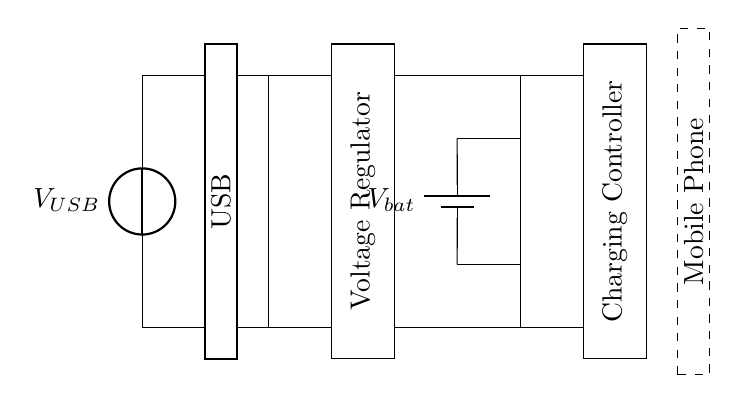What is the power source for this circuit? The power source for this circuit is a USB voltage source, indicated as V_USB. It is shown at the left side of the diagram and represents the input voltage that will charge the battery.
Answer: USB What component regulates the voltage in this circuit? The voltage regulation in this circuit is handled by the component labeled as Voltage Regulator. This component receives input voltage from the USB and ensures the output voltage is appropriate for charging the battery.
Answer: Voltage Regulator How many main components are visible in the circuit? There are five main components visible in the circuit: USB source, Voltage Regulator, Battery, Charging Controller, and Mobile Phone body. These elements work together to allow charging of the mobile device’s battery.
Answer: Five What does the battery symbol represent? The battery symbol represents V_bat, which indicates the battery in the circuit. It is responsible for storing the electrical energy that powers the mobile phone once charged.
Answer: Battery What is the purpose of the charging controller? The charging controller controls the flow of current from the voltage regulator to the battery, ensuring that the battery is charged safely and effectively while preventing overcharging.
Answer: Current control What voltage does the charging controller typically output? The charging controller typically outputs a voltage consistent with the battery's charging specifications, generally around 4.2V for lithium-ion batteries, which ensures maximum efficiency without risking battery damage.
Answer: 4.2V Which part of the circuit represents the mobile phone itself? The part of the circuit that represents the mobile phone is indicated by a dashed rectangle labeled Mobile Phone, placed at the far right of the circuit diagram. This is where the stored energy from the battery powers the phone.
Answer: Mobile Phone 